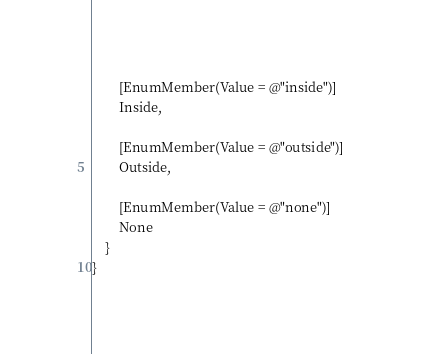<code> <loc_0><loc_0><loc_500><loc_500><_C#_>
        [EnumMember(Value = @"inside")]
        Inside,

        [EnumMember(Value = @"outside")]
        Outside,

        [EnumMember(Value = @"none")]
        None
    }
}
</code> 